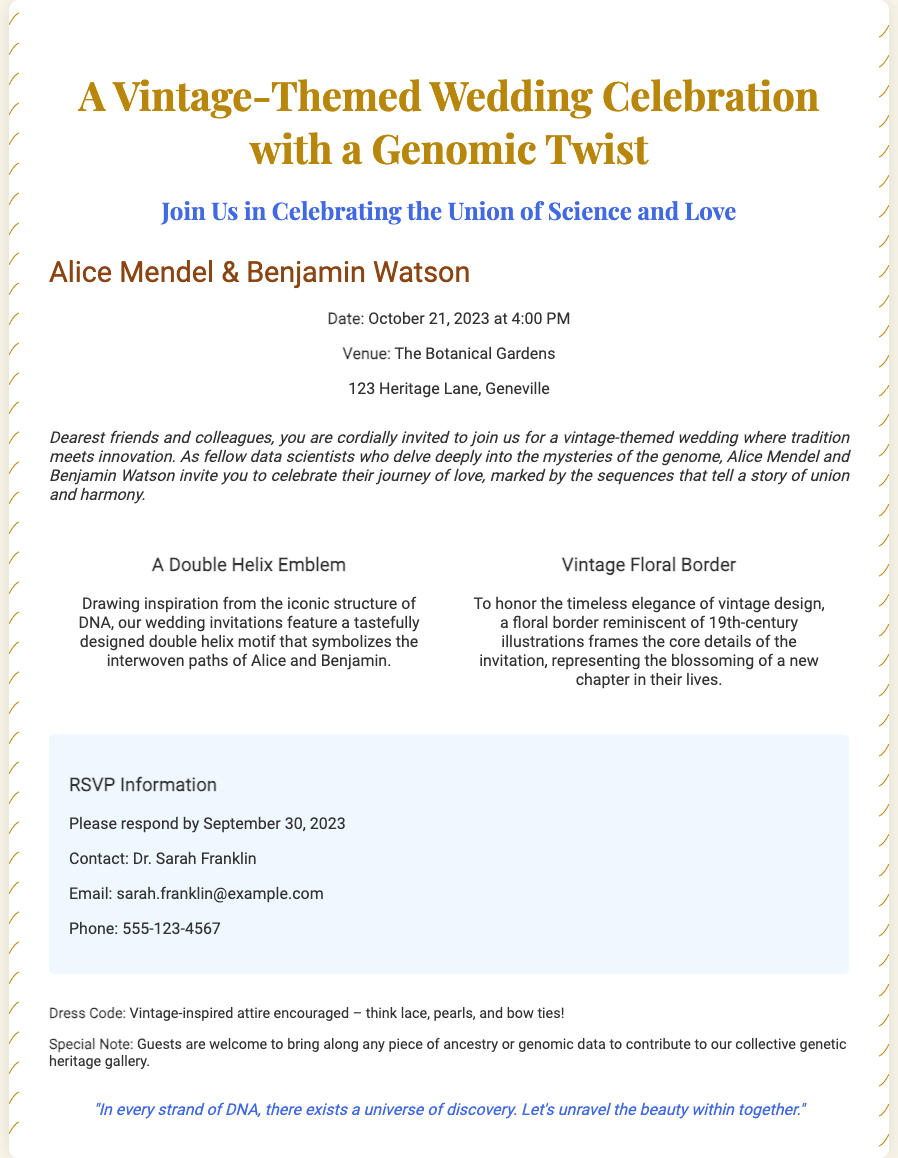What are the names of the couple? The couple's names are clearly stated in the invitation, which is Alice Mendel & Benjamin Watson.
Answer: Alice Mendel & Benjamin Watson What is the date of the wedding? The specific date of the wedding is mentioned in the details section of the invitation.
Answer: October 21, 2023 Where is the wedding venue? The venue where the wedding is taking place is listed within the details section.
Answer: The Botanical Gardens What is the RSVP deadline? The RSVP information provides a clear deadline for guests to respond.
Answer: September 30, 2023 What motif represents the couple's love? The invitation mentions a specific emblem that symbolizes the couple's relationship and love.
Answer: A Double Helix Emblem What dress code is encouraged? The additional notes provide guidance on the expected attire for guests at the wedding.
Answer: Vintage-inspired attire encouraged Who should be contacted for RSVP? The RSVP section details whom guests should reach out to for their responses, providing a specific name.
Answer: Dr. Sarah Franklin What is the color of the invitation's header text? The style of the header text is described in the document, indicating a specific color that is used.
Answer: #b8860b 